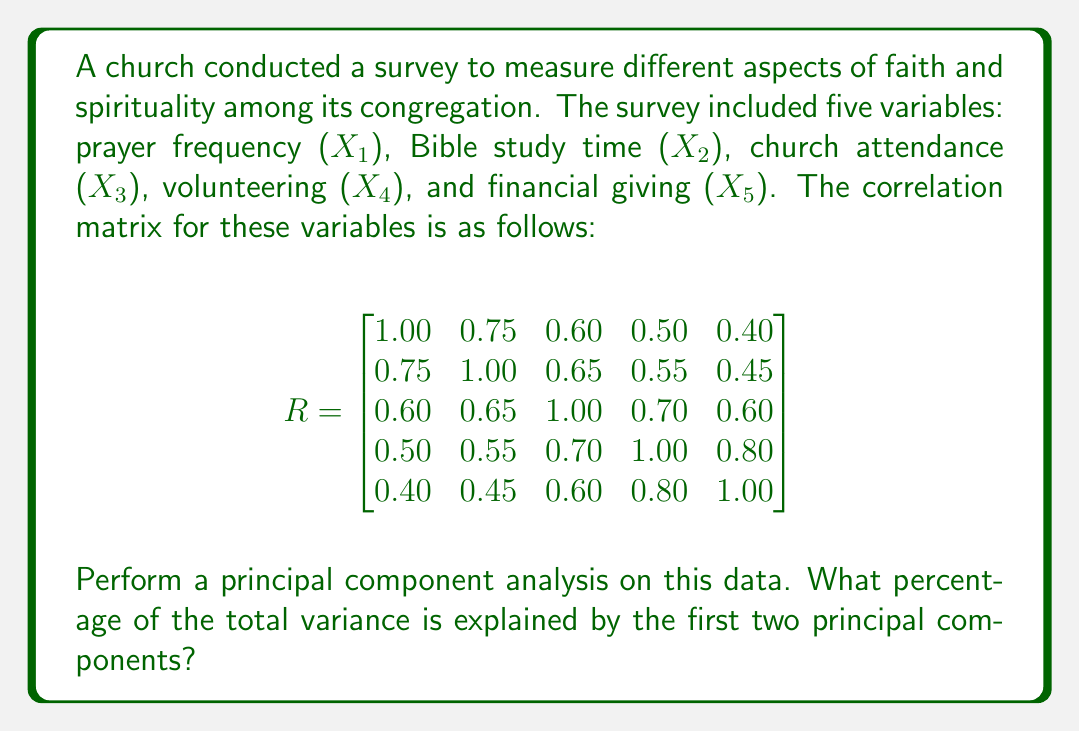What is the answer to this math problem? To perform principal component analysis (PCA) and determine the percentage of total variance explained by the first two principal components, we'll follow these steps:

1. Calculate the eigenvalues and eigenvectors of the correlation matrix.
2. Order the eigenvalues from largest to smallest.
3. Calculate the proportion of variance explained by each principal component.
4. Sum the proportions for the first two principal components.

Step 1: Calculate eigenvalues and eigenvectors
We need to solve the characteristic equation $|R - \lambda I| = 0$. This is a 5th-degree polynomial equation, which is complex to solve by hand. Using a computer algebra system or statistical software, we obtain the following eigenvalues:

$\lambda_1 = 3.4965$
$\lambda_2 = 0.6916$
$\lambda_3 = 0.3955$
$\lambda_4 = 0.2420$
$\lambda_5 = 0.1744$

Step 2: Order eigenvalues
The eigenvalues are already ordered from largest to smallest.

Step 3: Calculate proportion of variance explained
The proportion of variance explained by each principal component is calculated by dividing each eigenvalue by the sum of all eigenvalues:

Total variance = $\sum_{i=1}^5 \lambda_i = 3.4965 + 0.6916 + 0.3955 + 0.2420 + 0.1744 = 5$

Proportion of variance explained by PC1: $\frac{3.4965}{5} = 0.6993 = 69.93\%$
Proportion of variance explained by PC2: $\frac{0.6916}{5} = 0.1383 = 13.83\%$

Step 4: Sum proportions for first two principal components
Percentage of total variance explained by first two PCs:
$69.93\% + 13.83\% = 83.76\%$

Therefore, the first two principal components explain 83.76% of the total variance in the data.
Answer: The first two principal components explain 83.76% of the total variance in the faith and spirituality survey data. 